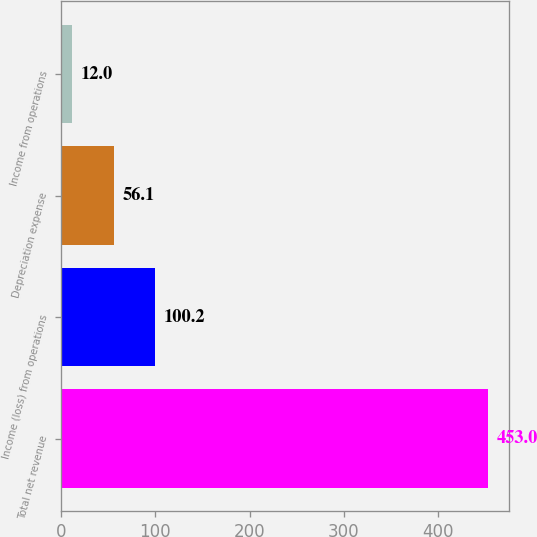Convert chart to OTSL. <chart><loc_0><loc_0><loc_500><loc_500><bar_chart><fcel>Total net revenue<fcel>Income (loss) from operations<fcel>Depreciation expense<fcel>Income from operations<nl><fcel>453<fcel>100.2<fcel>56.1<fcel>12<nl></chart> 